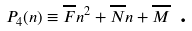<formula> <loc_0><loc_0><loc_500><loc_500>P _ { 4 } ( n ) \equiv \overline { F } n ^ { 2 } + \overline { N } n + \overline { M } \text { .}</formula> 